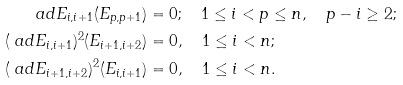Convert formula to latex. <formula><loc_0><loc_0><loc_500><loc_500>\ a d E _ { i , i + 1 } ( E _ { p , p + 1 } ) & = 0 ; \quad 1 \leq i < p \leq n , \quad p - i \geq 2 ; \\ ( \ a d E _ { i , i + 1 } ) ^ { 2 } ( E _ { i + 1 , i + 2 } ) & = 0 , \quad 1 \leq i < n ; \\ ( \ a d E _ { i + 1 , i + 2 } ) ^ { 2 } ( E _ { i , i + 1 } ) & = 0 , \quad 1 \leq i < n .</formula> 